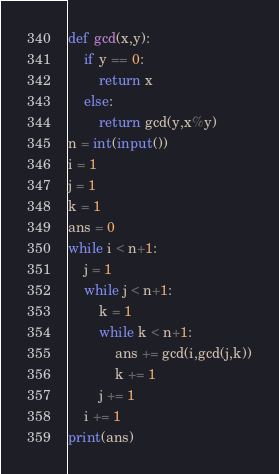<code> <loc_0><loc_0><loc_500><loc_500><_Python_>def gcd(x,y):
    if y == 0:
        return x
    else:
        return gcd(y,x%y)
n = int(input())
i = 1
j = 1
k = 1
ans = 0
while i < n+1:
    j = 1
    while j < n+1:
        k = 1
        while k < n+1:
            ans += gcd(i,gcd(j,k))
            k += 1
        j += 1
    i += 1
print(ans)</code> 